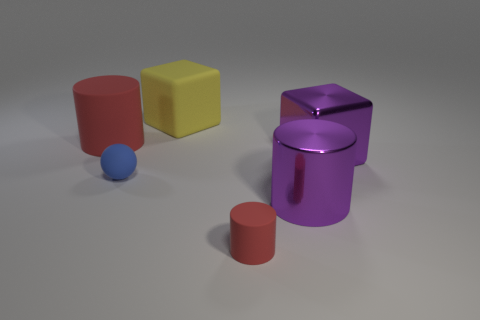Add 2 small cyan cylinders. How many objects exist? 8 Subtract all big cylinders. How many cylinders are left? 1 Subtract all purple cylinders. How many cylinders are left? 2 Subtract all red balls. How many green cubes are left? 0 Subtract all cubes. How many objects are left? 4 Subtract 1 cubes. How many cubes are left? 1 Subtract all gray cylinders. Subtract all yellow cubes. How many cylinders are left? 3 Subtract all big yellow rubber cubes. Subtract all big rubber objects. How many objects are left? 3 Add 1 yellow rubber things. How many yellow rubber things are left? 2 Add 3 brown metal things. How many brown metal things exist? 3 